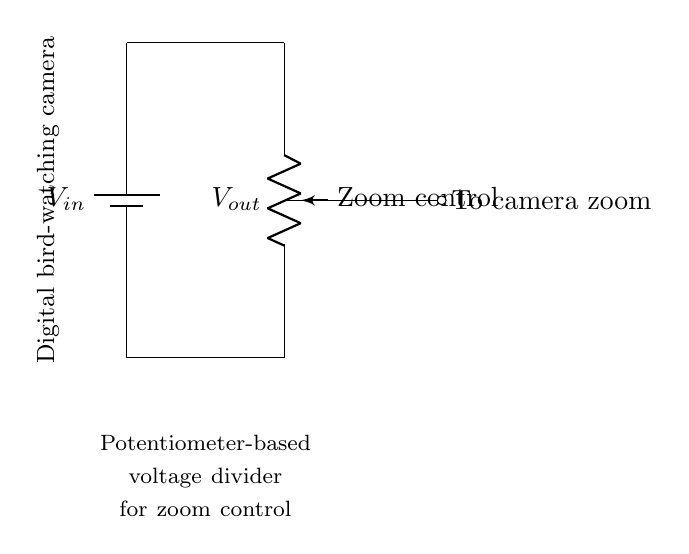What is the input voltage in this circuit? The input voltage is denoted as V_in at the battery. It is the voltage supplied to the circuit and indicated directly on the battery symbol.
Answer: V_in What does the potentiometer control? The potentiometer is labeled as "Zoom control" in the circuit diagram, indicating that it adjusts the voltage for controlling the zoom feature of the camera.
Answer: Zoom feature What is the output voltage's position in the circuit? The output voltage, labeled as V_out, is taken from the middle terminal of the potentiometer, which is used to send voltage to the camera.
Answer: Middle of the potentiometer How many connection points does the potentiometer have? A standard potentiometer has three connection points: the two ends and the wiper or middle connection. The diagram confirms this configuration.
Answer: Three What is the purpose of the short indicated in the circuit? The short represents a direct electrical connection between points with no resistance, ensuring that current flows uninterrupted from the bottom of the battery to the potentiometer and back.
Answer: Direct connection Which component provides power to the circuit? The battery (represented by the symbol) is the component that provides power to the entire circuit, as it supplies the input voltage.
Answer: Battery What happens when the potentiometer is adjusted? Adjusting the potentiometer changes the resistance, which varies the output voltage delivered to the camera, thereby controlling the zoom level dynamically.
Answer: Varies output voltage 